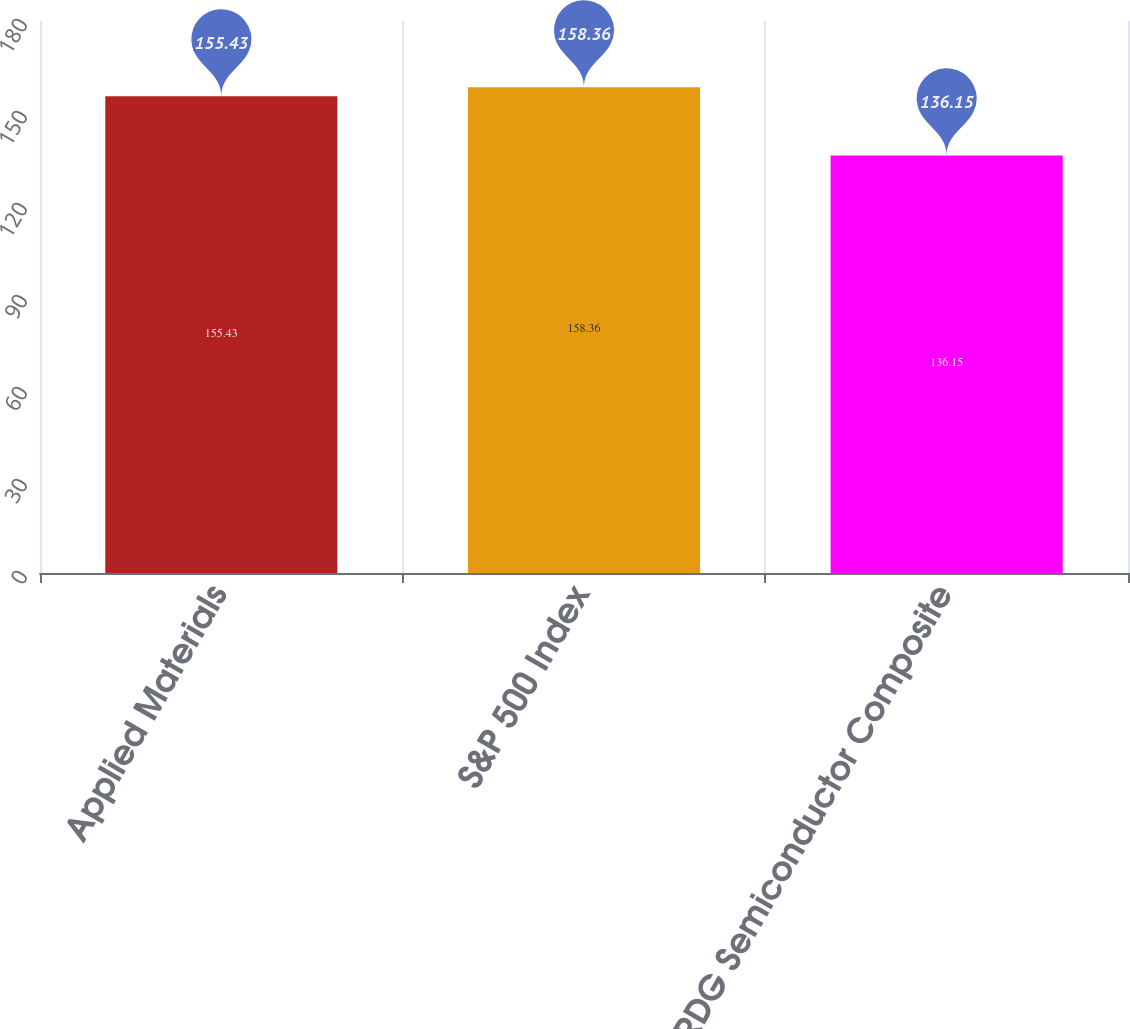Convert chart. <chart><loc_0><loc_0><loc_500><loc_500><bar_chart><fcel>Applied Materials<fcel>S&P 500 Index<fcel>RDG Semiconductor Composite<nl><fcel>155.43<fcel>158.36<fcel>136.15<nl></chart> 